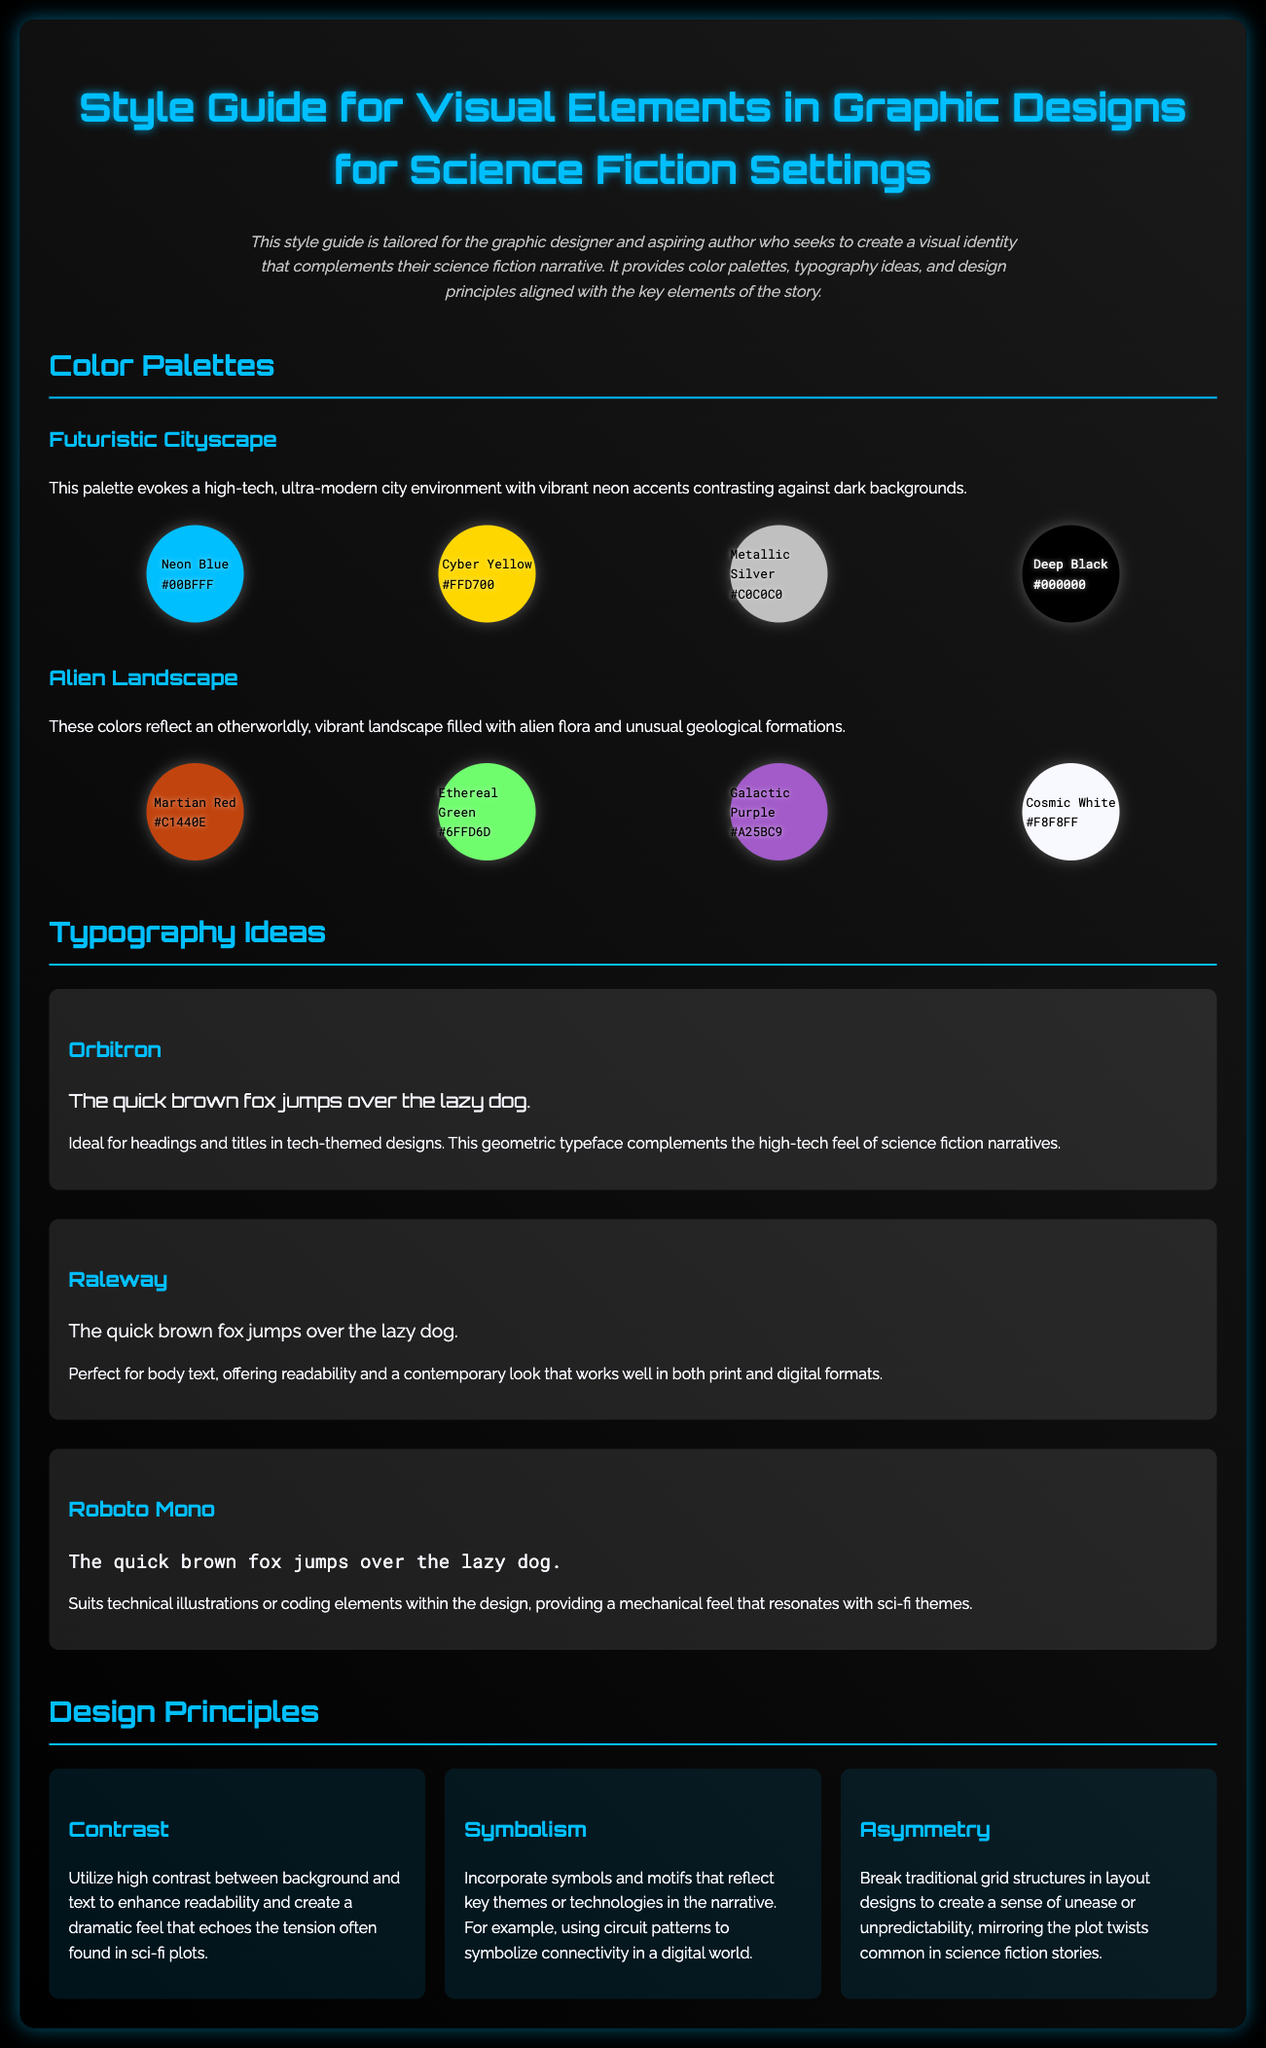What is the background color of the body? The background color of the body is specified in the style section as black.
Answer: black How many color swatches are there in the Futuristic Cityscape palette? The Futuristic Cityscape palette contains four color swatches listed in the document.
Answer: four What is the name of the font used for headings? The font for headings is specified as 'Orbitron' in the typography section of the document.
Answer: Orbitron What is the primary purpose of the style guide? The style guide aims to help graphic designers and authors create a visual identity that complements their science fiction narrative.
Answer: visual identity Which color represents Martian Red? The color swatch labeled Martian Red has the hex code #C1440E in the Alien Landscape palette.
Answer: #C1440E What design principle involves utilizing high contrast? The principle concerned with using high contrast between background and text to enhance readability is named 'Contrast.'
Answer: Contrast Name one of the typefaces suitable for body text. Raleway is identified as a suitable typeface for body text in the typography section.
Answer: Raleway What color is used for the Deep Black swatch? The color used for the Deep Black swatch is black, with the text displayed in white.
Answer: black 